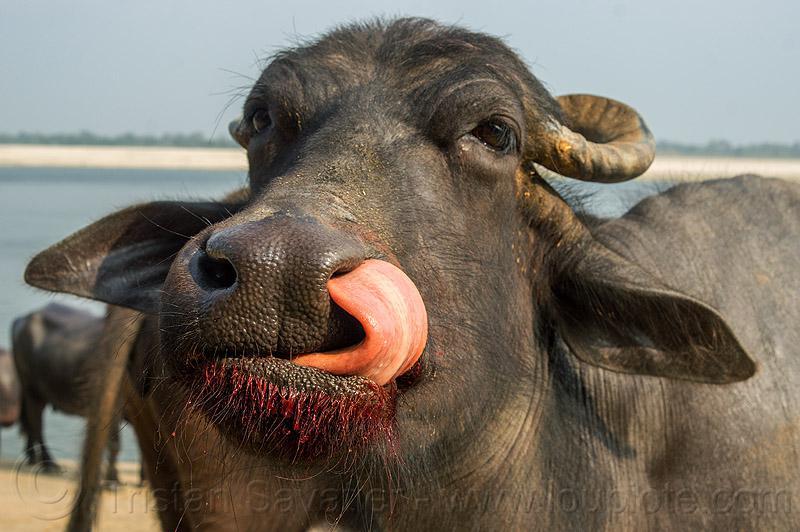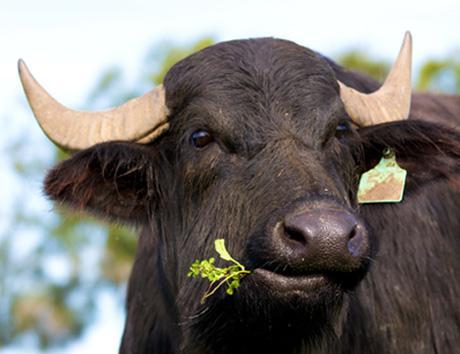The first image is the image on the left, the second image is the image on the right. For the images shown, is this caption "Each image includes a water buffalo with its face mostly forward." true? Answer yes or no. Yes. The first image is the image on the left, the second image is the image on the right. For the images displayed, is the sentence "In each image, there is at least one cow looking directly at the camera." factually correct? Answer yes or no. Yes. 